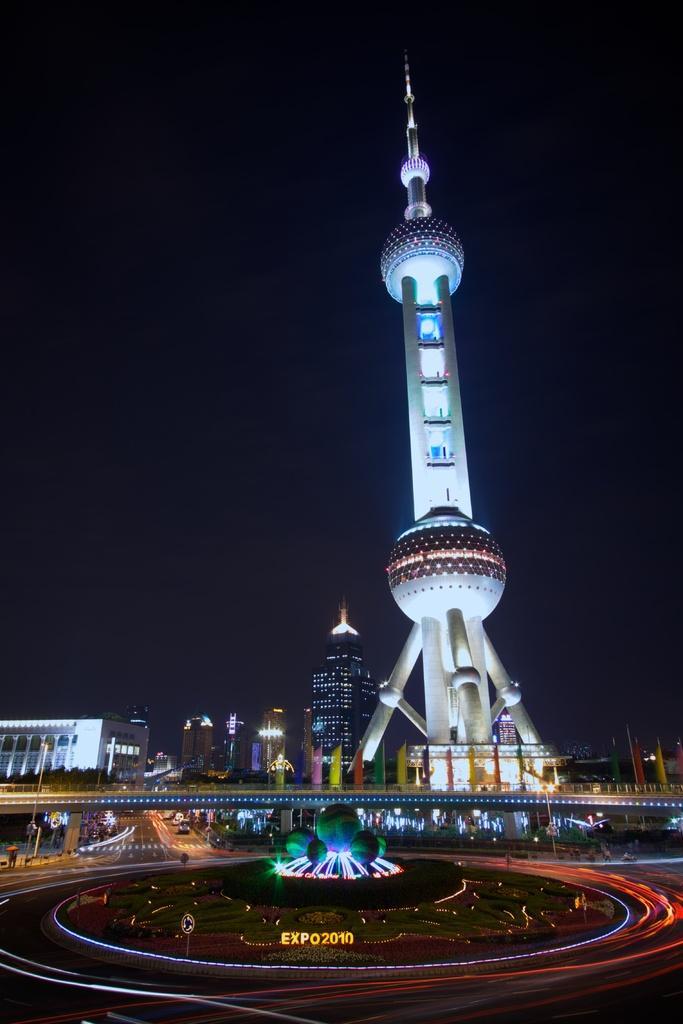Describe this image in one or two sentences. This image is taken outdoors. The background is dark. At the bottom of the image there are a few road and many vehicles are moving on the roads. In the middle of the image there is a bridge, a fountain with lamps and many houses, buildings and towers. 